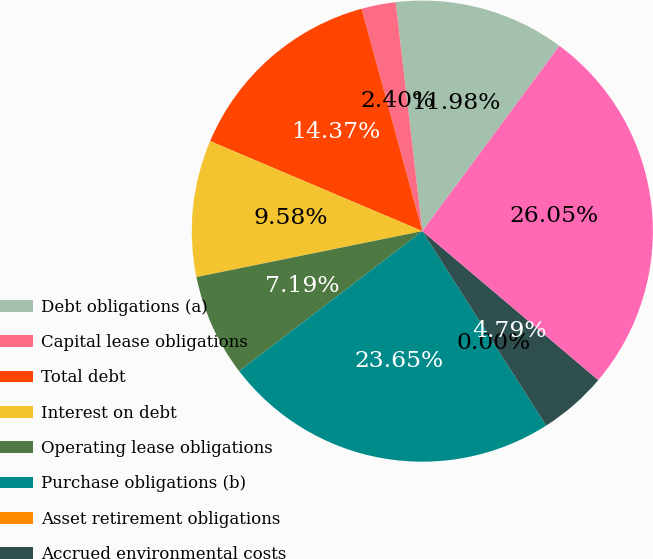Convert chart to OTSL. <chart><loc_0><loc_0><loc_500><loc_500><pie_chart><fcel>Debt obligations (a)<fcel>Capital lease obligations<fcel>Total debt<fcel>Interest on debt<fcel>Operating lease obligations<fcel>Purchase obligations (b)<fcel>Asset retirement obligations<fcel>Accrued environmental costs<fcel>Total<nl><fcel>11.98%<fcel>2.4%<fcel>14.37%<fcel>9.58%<fcel>7.19%<fcel>23.65%<fcel>0.0%<fcel>4.79%<fcel>26.05%<nl></chart> 